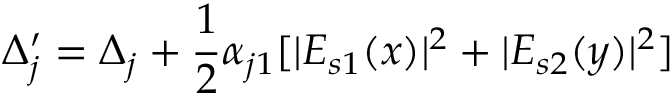<formula> <loc_0><loc_0><loc_500><loc_500>\Delta _ { j } ^ { \prime } = \Delta _ { j } + \frac { 1 } { 2 } \alpha _ { j 1 } [ | E _ { s 1 } ( x ) | ^ { 2 } + | E _ { s 2 } ( y ) | ^ { 2 } ]</formula> 